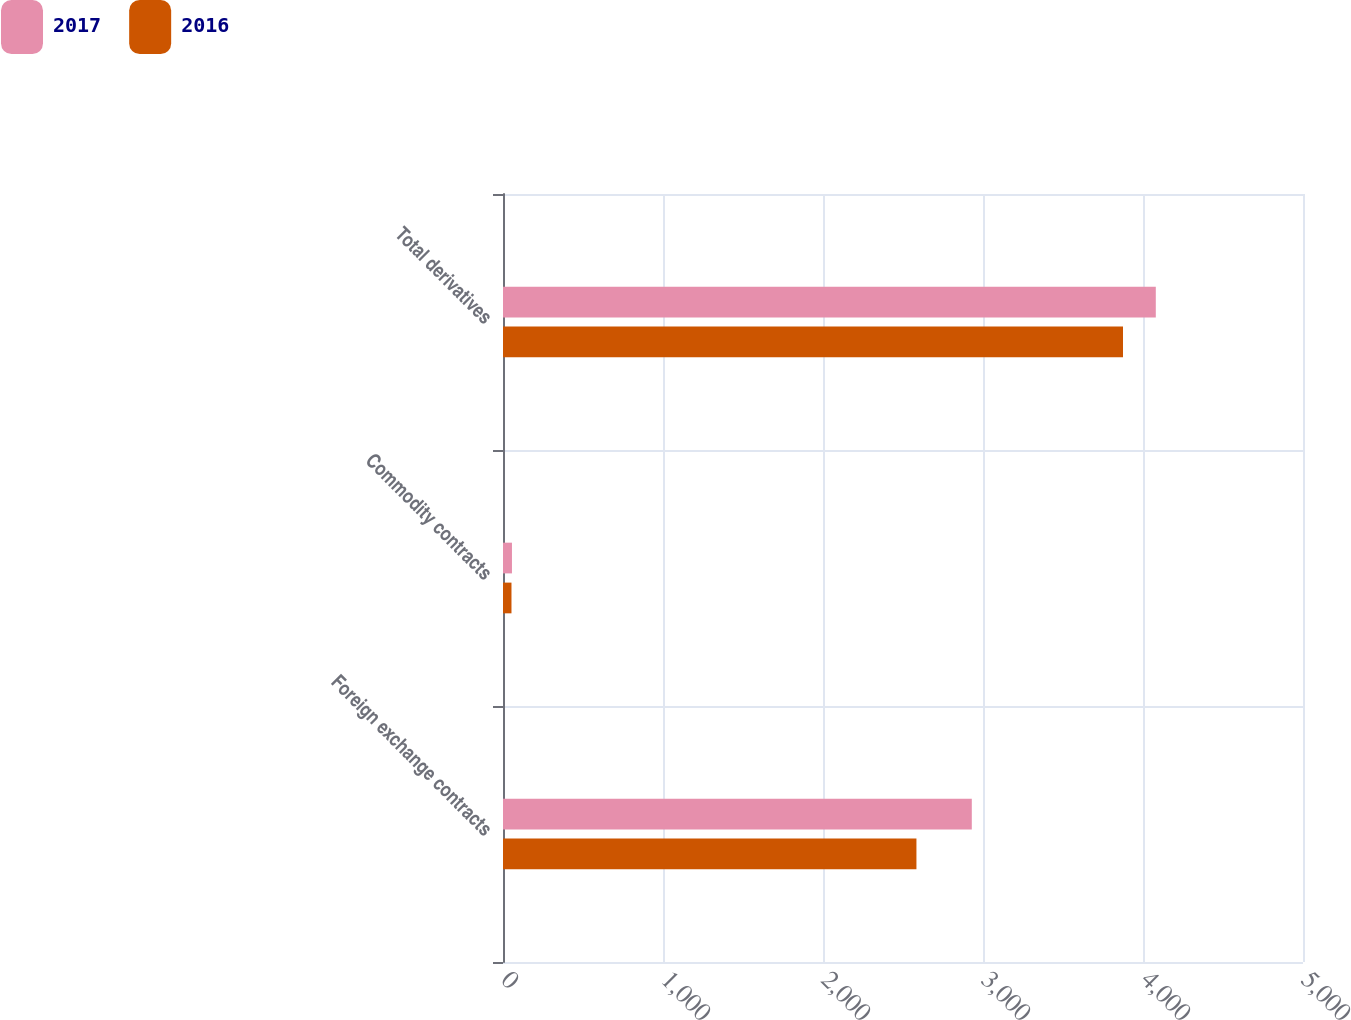Convert chart. <chart><loc_0><loc_0><loc_500><loc_500><stacked_bar_chart><ecel><fcel>Foreign exchange contracts<fcel>Commodity contracts<fcel>Total derivatives<nl><fcel>2017<fcel>2930<fcel>56<fcel>4080<nl><fcel>2016<fcel>2584<fcel>53<fcel>3875<nl></chart> 